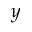<formula> <loc_0><loc_0><loc_500><loc_500>y</formula> 